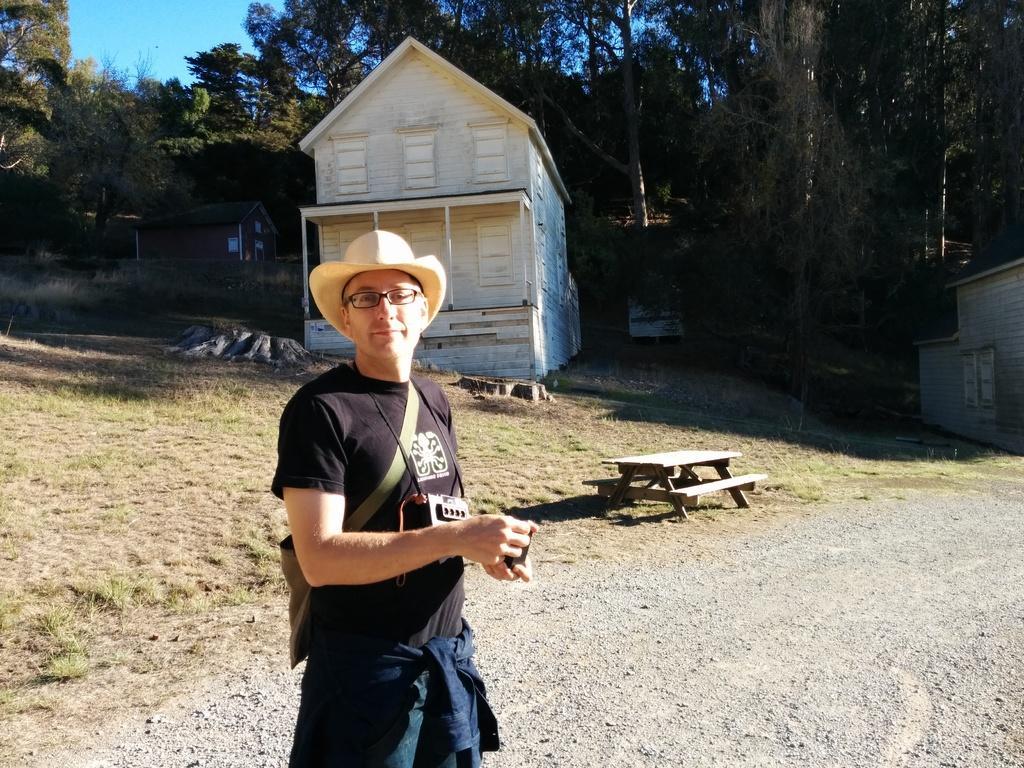Can you describe this image briefly? This picture is of outside. In the foreground we can see a man wearing black color t-shirt and standing, behind him we can see a house, a bench. In the background there is a sky, some trees, house and we can see the ground with grass. 